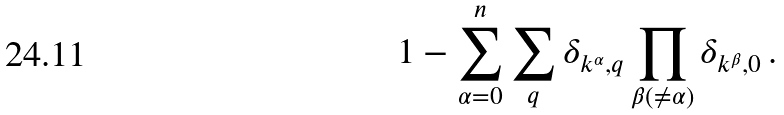Convert formula to latex. <formula><loc_0><loc_0><loc_500><loc_500>1 - \sum _ { \alpha = 0 } ^ { n } \sum _ { q } \delta _ { { k } ^ { \alpha } , { q } } \prod _ { \beta ( \ne \alpha ) } \delta _ { { k } ^ { \beta } , { 0 } } \, .</formula> 